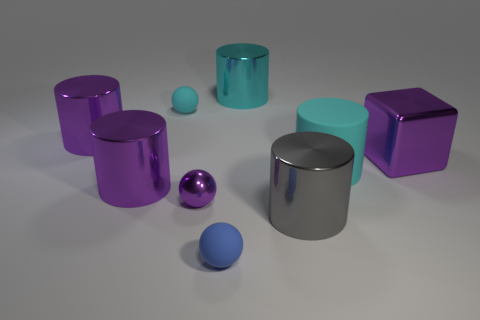Are there fewer matte things on the right side of the large rubber cylinder than big things?
Provide a short and direct response. Yes. Is there a big rubber thing that has the same shape as the gray metal object?
Offer a terse response. Yes. There is a cyan metal object that is the same size as the gray metal thing; what is its shape?
Offer a terse response. Cylinder. How many things are purple blocks or purple cylinders?
Provide a short and direct response. 3. Are there any big brown metallic blocks?
Give a very brief answer. No. Are there fewer purple cubes than small spheres?
Your response must be concise. Yes. Are there any other shiny spheres that have the same size as the cyan ball?
Offer a very short reply. Yes. Does the large cyan rubber object have the same shape as the large cyan object behind the cyan matte ball?
Give a very brief answer. Yes. What number of balls are small rubber objects or small blue objects?
Your answer should be very brief. 2. What color is the large cube?
Ensure brevity in your answer.  Purple. 